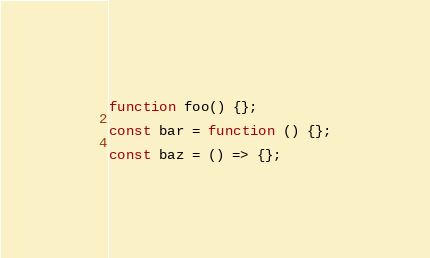<code> <loc_0><loc_0><loc_500><loc_500><_JavaScript_>function foo() {};

const bar = function () {};

const baz = () => {};
</code> 